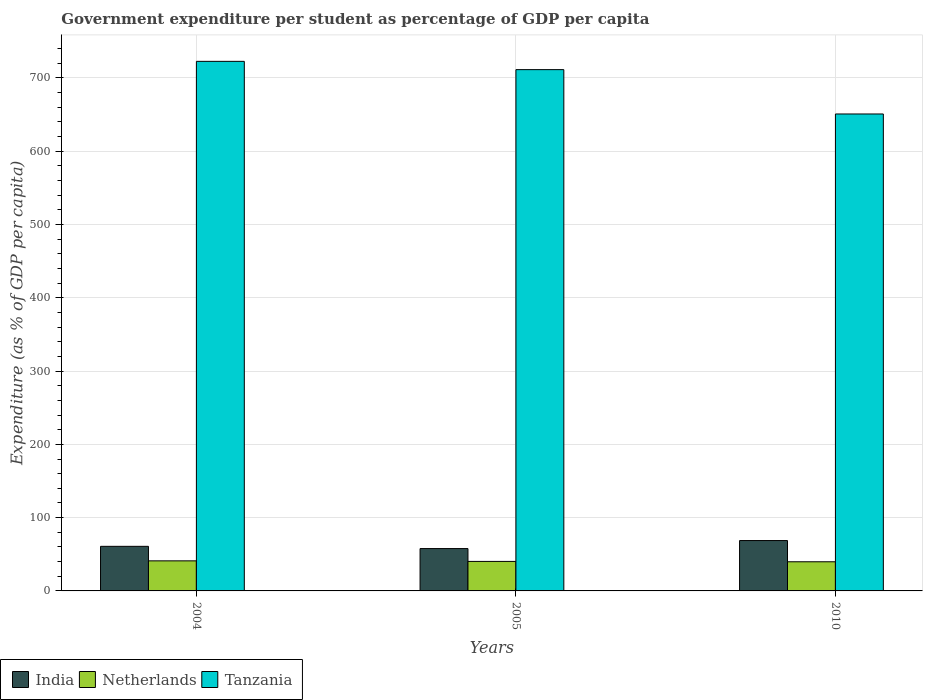How many bars are there on the 2nd tick from the right?
Offer a very short reply. 3. What is the label of the 1st group of bars from the left?
Offer a terse response. 2004. In how many cases, is the number of bars for a given year not equal to the number of legend labels?
Keep it short and to the point. 0. What is the percentage of expenditure per student in Netherlands in 2004?
Offer a terse response. 41.03. Across all years, what is the maximum percentage of expenditure per student in India?
Your answer should be compact. 68.72. Across all years, what is the minimum percentage of expenditure per student in Netherlands?
Your answer should be compact. 39.78. In which year was the percentage of expenditure per student in Tanzania minimum?
Offer a very short reply. 2010. What is the total percentage of expenditure per student in India in the graph?
Keep it short and to the point. 187.35. What is the difference between the percentage of expenditure per student in Tanzania in 2004 and that in 2005?
Provide a short and direct response. 11.29. What is the difference between the percentage of expenditure per student in Netherlands in 2010 and the percentage of expenditure per student in Tanzania in 2005?
Your answer should be very brief. -671.52. What is the average percentage of expenditure per student in India per year?
Make the answer very short. 62.45. In the year 2005, what is the difference between the percentage of expenditure per student in Tanzania and percentage of expenditure per student in Netherlands?
Your response must be concise. 671.04. In how many years, is the percentage of expenditure per student in Tanzania greater than 600 %?
Offer a terse response. 3. What is the ratio of the percentage of expenditure per student in Tanzania in 2004 to that in 2010?
Offer a terse response. 1.11. Is the percentage of expenditure per student in Netherlands in 2005 less than that in 2010?
Keep it short and to the point. No. What is the difference between the highest and the second highest percentage of expenditure per student in India?
Offer a terse response. 7.87. What is the difference between the highest and the lowest percentage of expenditure per student in Netherlands?
Ensure brevity in your answer.  1.25. In how many years, is the percentage of expenditure per student in Netherlands greater than the average percentage of expenditure per student in Netherlands taken over all years?
Your answer should be very brief. 1. Is the sum of the percentage of expenditure per student in Netherlands in 2004 and 2005 greater than the maximum percentage of expenditure per student in India across all years?
Offer a terse response. Yes. What does the 1st bar from the left in 2005 represents?
Your answer should be very brief. India. What does the 1st bar from the right in 2004 represents?
Ensure brevity in your answer.  Tanzania. Is it the case that in every year, the sum of the percentage of expenditure per student in Tanzania and percentage of expenditure per student in India is greater than the percentage of expenditure per student in Netherlands?
Give a very brief answer. Yes. Are all the bars in the graph horizontal?
Your response must be concise. No. How many years are there in the graph?
Ensure brevity in your answer.  3. Does the graph contain any zero values?
Keep it short and to the point. No. Does the graph contain grids?
Offer a terse response. Yes. Where does the legend appear in the graph?
Offer a very short reply. Bottom left. How many legend labels are there?
Provide a short and direct response. 3. What is the title of the graph?
Provide a short and direct response. Government expenditure per student as percentage of GDP per capita. Does "Bahamas" appear as one of the legend labels in the graph?
Provide a short and direct response. No. What is the label or title of the Y-axis?
Provide a succinct answer. Expenditure (as % of GDP per capita). What is the Expenditure (as % of GDP per capita) in India in 2004?
Keep it short and to the point. 60.85. What is the Expenditure (as % of GDP per capita) in Netherlands in 2004?
Offer a very short reply. 41.03. What is the Expenditure (as % of GDP per capita) in Tanzania in 2004?
Make the answer very short. 722.6. What is the Expenditure (as % of GDP per capita) in India in 2005?
Offer a terse response. 57.79. What is the Expenditure (as % of GDP per capita) in Netherlands in 2005?
Make the answer very short. 40.26. What is the Expenditure (as % of GDP per capita) in Tanzania in 2005?
Offer a terse response. 711.3. What is the Expenditure (as % of GDP per capita) of India in 2010?
Your answer should be very brief. 68.72. What is the Expenditure (as % of GDP per capita) in Netherlands in 2010?
Keep it short and to the point. 39.78. What is the Expenditure (as % of GDP per capita) of Tanzania in 2010?
Ensure brevity in your answer.  650.78. Across all years, what is the maximum Expenditure (as % of GDP per capita) of India?
Keep it short and to the point. 68.72. Across all years, what is the maximum Expenditure (as % of GDP per capita) of Netherlands?
Offer a terse response. 41.03. Across all years, what is the maximum Expenditure (as % of GDP per capita) of Tanzania?
Offer a terse response. 722.6. Across all years, what is the minimum Expenditure (as % of GDP per capita) of India?
Offer a very short reply. 57.79. Across all years, what is the minimum Expenditure (as % of GDP per capita) of Netherlands?
Your answer should be very brief. 39.78. Across all years, what is the minimum Expenditure (as % of GDP per capita) in Tanzania?
Keep it short and to the point. 650.78. What is the total Expenditure (as % of GDP per capita) in India in the graph?
Ensure brevity in your answer.  187.35. What is the total Expenditure (as % of GDP per capita) in Netherlands in the graph?
Your answer should be very brief. 121.07. What is the total Expenditure (as % of GDP per capita) in Tanzania in the graph?
Your response must be concise. 2084.68. What is the difference between the Expenditure (as % of GDP per capita) of India in 2004 and that in 2005?
Give a very brief answer. 3.06. What is the difference between the Expenditure (as % of GDP per capita) in Netherlands in 2004 and that in 2005?
Make the answer very short. 0.77. What is the difference between the Expenditure (as % of GDP per capita) in Tanzania in 2004 and that in 2005?
Make the answer very short. 11.29. What is the difference between the Expenditure (as % of GDP per capita) in India in 2004 and that in 2010?
Give a very brief answer. -7.87. What is the difference between the Expenditure (as % of GDP per capita) in Netherlands in 2004 and that in 2010?
Provide a succinct answer. 1.25. What is the difference between the Expenditure (as % of GDP per capita) of Tanzania in 2004 and that in 2010?
Provide a succinct answer. 71.81. What is the difference between the Expenditure (as % of GDP per capita) in India in 2005 and that in 2010?
Your answer should be compact. -10.93. What is the difference between the Expenditure (as % of GDP per capita) in Netherlands in 2005 and that in 2010?
Your answer should be very brief. 0.48. What is the difference between the Expenditure (as % of GDP per capita) in Tanzania in 2005 and that in 2010?
Make the answer very short. 60.52. What is the difference between the Expenditure (as % of GDP per capita) in India in 2004 and the Expenditure (as % of GDP per capita) in Netherlands in 2005?
Ensure brevity in your answer.  20.58. What is the difference between the Expenditure (as % of GDP per capita) in India in 2004 and the Expenditure (as % of GDP per capita) in Tanzania in 2005?
Offer a terse response. -650.46. What is the difference between the Expenditure (as % of GDP per capita) of Netherlands in 2004 and the Expenditure (as % of GDP per capita) of Tanzania in 2005?
Make the answer very short. -670.27. What is the difference between the Expenditure (as % of GDP per capita) of India in 2004 and the Expenditure (as % of GDP per capita) of Netherlands in 2010?
Provide a short and direct response. 21.07. What is the difference between the Expenditure (as % of GDP per capita) of India in 2004 and the Expenditure (as % of GDP per capita) of Tanzania in 2010?
Provide a succinct answer. -589.94. What is the difference between the Expenditure (as % of GDP per capita) of Netherlands in 2004 and the Expenditure (as % of GDP per capita) of Tanzania in 2010?
Your answer should be very brief. -609.75. What is the difference between the Expenditure (as % of GDP per capita) in India in 2005 and the Expenditure (as % of GDP per capita) in Netherlands in 2010?
Your answer should be compact. 18.01. What is the difference between the Expenditure (as % of GDP per capita) in India in 2005 and the Expenditure (as % of GDP per capita) in Tanzania in 2010?
Make the answer very short. -592.99. What is the difference between the Expenditure (as % of GDP per capita) of Netherlands in 2005 and the Expenditure (as % of GDP per capita) of Tanzania in 2010?
Make the answer very short. -610.52. What is the average Expenditure (as % of GDP per capita) of India per year?
Ensure brevity in your answer.  62.45. What is the average Expenditure (as % of GDP per capita) of Netherlands per year?
Keep it short and to the point. 40.36. What is the average Expenditure (as % of GDP per capita) in Tanzania per year?
Make the answer very short. 694.89. In the year 2004, what is the difference between the Expenditure (as % of GDP per capita) in India and Expenditure (as % of GDP per capita) in Netherlands?
Offer a very short reply. 19.81. In the year 2004, what is the difference between the Expenditure (as % of GDP per capita) in India and Expenditure (as % of GDP per capita) in Tanzania?
Give a very brief answer. -661.75. In the year 2004, what is the difference between the Expenditure (as % of GDP per capita) of Netherlands and Expenditure (as % of GDP per capita) of Tanzania?
Offer a very short reply. -681.56. In the year 2005, what is the difference between the Expenditure (as % of GDP per capita) of India and Expenditure (as % of GDP per capita) of Netherlands?
Ensure brevity in your answer.  17.53. In the year 2005, what is the difference between the Expenditure (as % of GDP per capita) of India and Expenditure (as % of GDP per capita) of Tanzania?
Ensure brevity in your answer.  -653.51. In the year 2005, what is the difference between the Expenditure (as % of GDP per capita) of Netherlands and Expenditure (as % of GDP per capita) of Tanzania?
Your answer should be compact. -671.04. In the year 2010, what is the difference between the Expenditure (as % of GDP per capita) of India and Expenditure (as % of GDP per capita) of Netherlands?
Make the answer very short. 28.94. In the year 2010, what is the difference between the Expenditure (as % of GDP per capita) in India and Expenditure (as % of GDP per capita) in Tanzania?
Ensure brevity in your answer.  -582.06. In the year 2010, what is the difference between the Expenditure (as % of GDP per capita) of Netherlands and Expenditure (as % of GDP per capita) of Tanzania?
Provide a succinct answer. -611. What is the ratio of the Expenditure (as % of GDP per capita) of India in 2004 to that in 2005?
Keep it short and to the point. 1.05. What is the ratio of the Expenditure (as % of GDP per capita) of Netherlands in 2004 to that in 2005?
Your response must be concise. 1.02. What is the ratio of the Expenditure (as % of GDP per capita) of Tanzania in 2004 to that in 2005?
Make the answer very short. 1.02. What is the ratio of the Expenditure (as % of GDP per capita) in India in 2004 to that in 2010?
Make the answer very short. 0.89. What is the ratio of the Expenditure (as % of GDP per capita) of Netherlands in 2004 to that in 2010?
Offer a very short reply. 1.03. What is the ratio of the Expenditure (as % of GDP per capita) of Tanzania in 2004 to that in 2010?
Your answer should be very brief. 1.11. What is the ratio of the Expenditure (as % of GDP per capita) of India in 2005 to that in 2010?
Your answer should be compact. 0.84. What is the ratio of the Expenditure (as % of GDP per capita) in Netherlands in 2005 to that in 2010?
Provide a succinct answer. 1.01. What is the ratio of the Expenditure (as % of GDP per capita) of Tanzania in 2005 to that in 2010?
Ensure brevity in your answer.  1.09. What is the difference between the highest and the second highest Expenditure (as % of GDP per capita) of India?
Your response must be concise. 7.87. What is the difference between the highest and the second highest Expenditure (as % of GDP per capita) of Netherlands?
Keep it short and to the point. 0.77. What is the difference between the highest and the second highest Expenditure (as % of GDP per capita) in Tanzania?
Your response must be concise. 11.29. What is the difference between the highest and the lowest Expenditure (as % of GDP per capita) of India?
Offer a very short reply. 10.93. What is the difference between the highest and the lowest Expenditure (as % of GDP per capita) of Netherlands?
Offer a very short reply. 1.25. What is the difference between the highest and the lowest Expenditure (as % of GDP per capita) in Tanzania?
Make the answer very short. 71.81. 